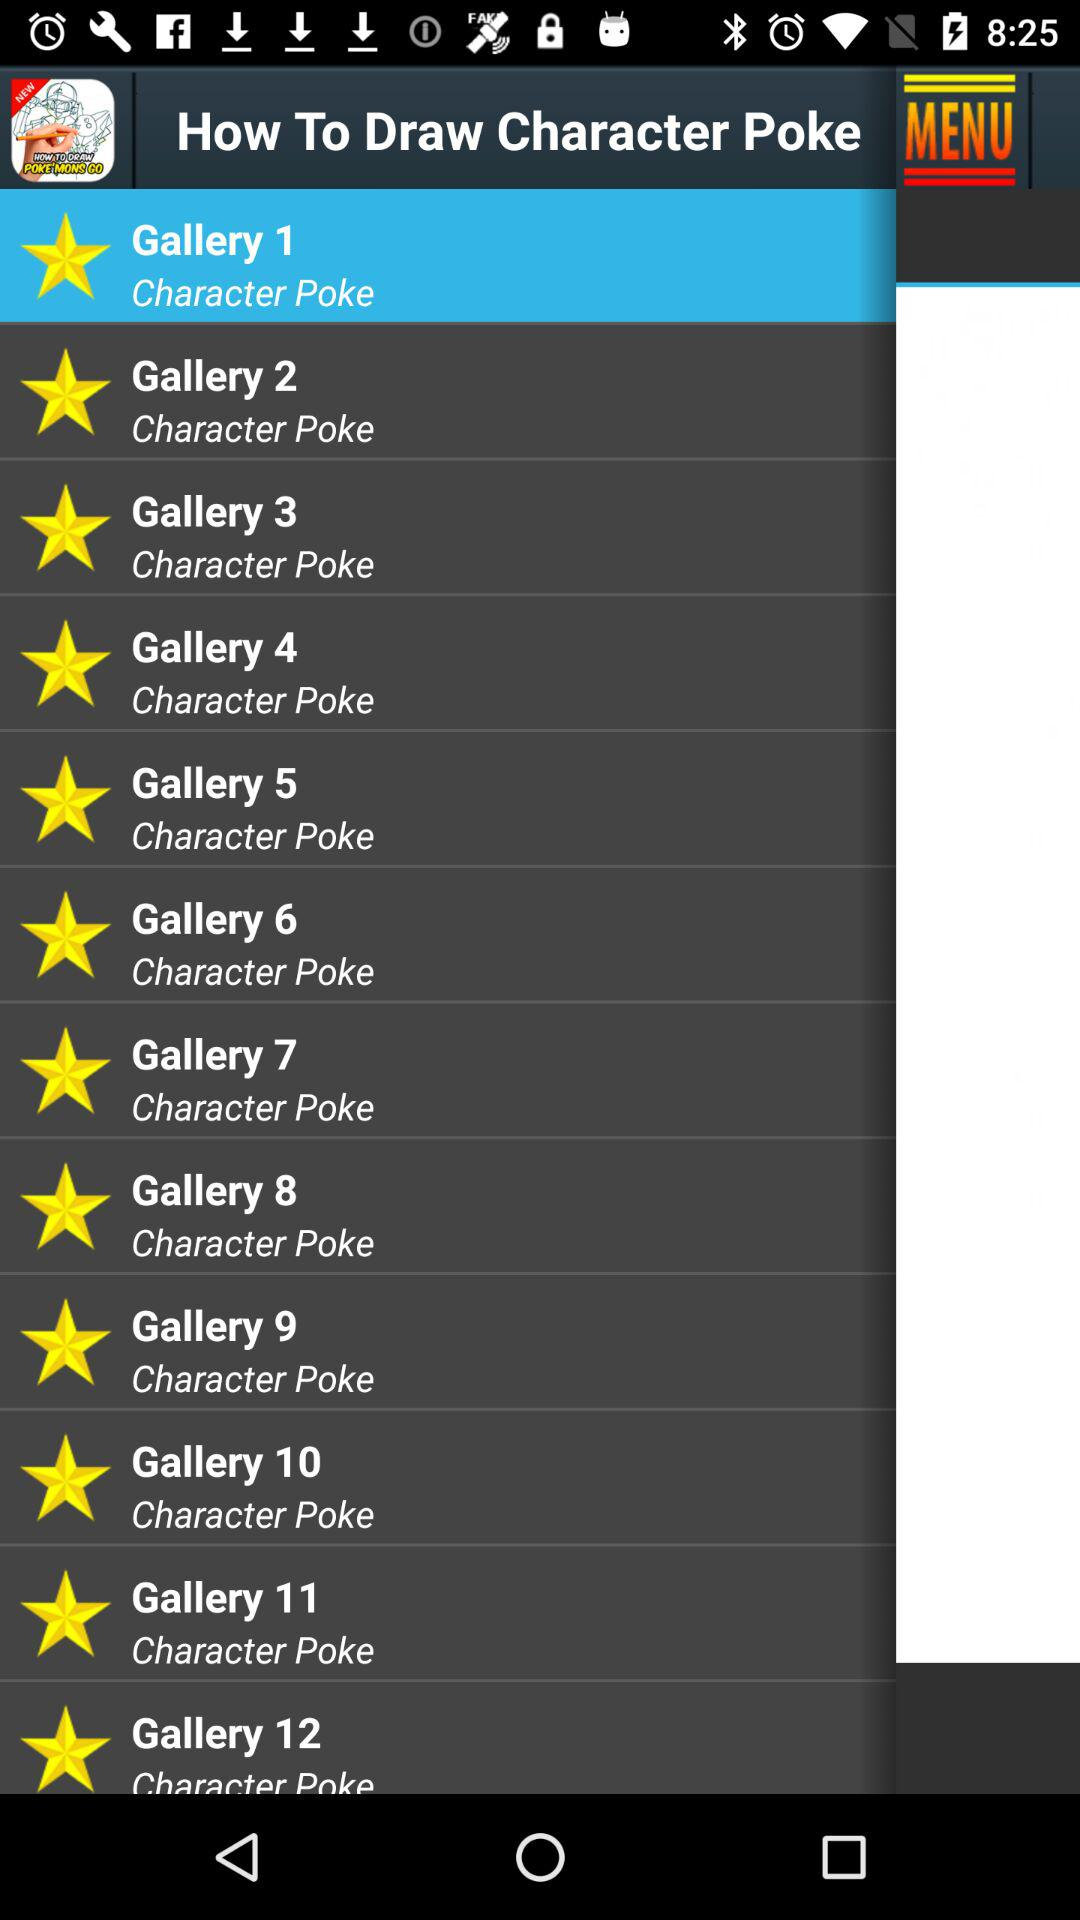How many galleries are there in total?
Answer the question using a single word or phrase. 12 